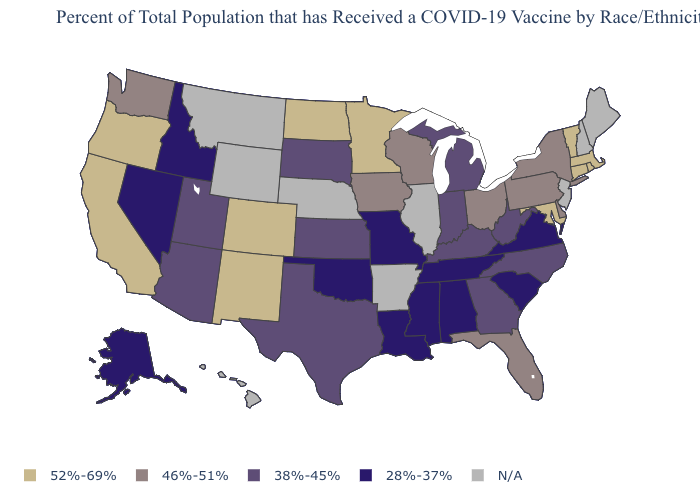Name the states that have a value in the range 52%-69%?
Concise answer only. California, Colorado, Connecticut, Maryland, Massachusetts, Minnesota, New Mexico, North Dakota, Oregon, Rhode Island, Vermont. What is the value of Kansas?
Be succinct. 38%-45%. What is the lowest value in the USA?
Short answer required. 28%-37%. What is the value of Virginia?
Concise answer only. 28%-37%. Does the first symbol in the legend represent the smallest category?
Answer briefly. No. Which states hav the highest value in the MidWest?
Be succinct. Minnesota, North Dakota. Name the states that have a value in the range 52%-69%?
Short answer required. California, Colorado, Connecticut, Maryland, Massachusetts, Minnesota, New Mexico, North Dakota, Oregon, Rhode Island, Vermont. Among the states that border Nevada , which have the highest value?
Quick response, please. California, Oregon. Name the states that have a value in the range 28%-37%?
Concise answer only. Alabama, Alaska, Idaho, Louisiana, Mississippi, Missouri, Nevada, Oklahoma, South Carolina, Tennessee, Virginia. Among the states that border Alabama , which have the lowest value?
Be succinct. Mississippi, Tennessee. Name the states that have a value in the range 52%-69%?
Answer briefly. California, Colorado, Connecticut, Maryland, Massachusetts, Minnesota, New Mexico, North Dakota, Oregon, Rhode Island, Vermont. How many symbols are there in the legend?
Quick response, please. 5. What is the lowest value in the USA?
Be succinct. 28%-37%. 